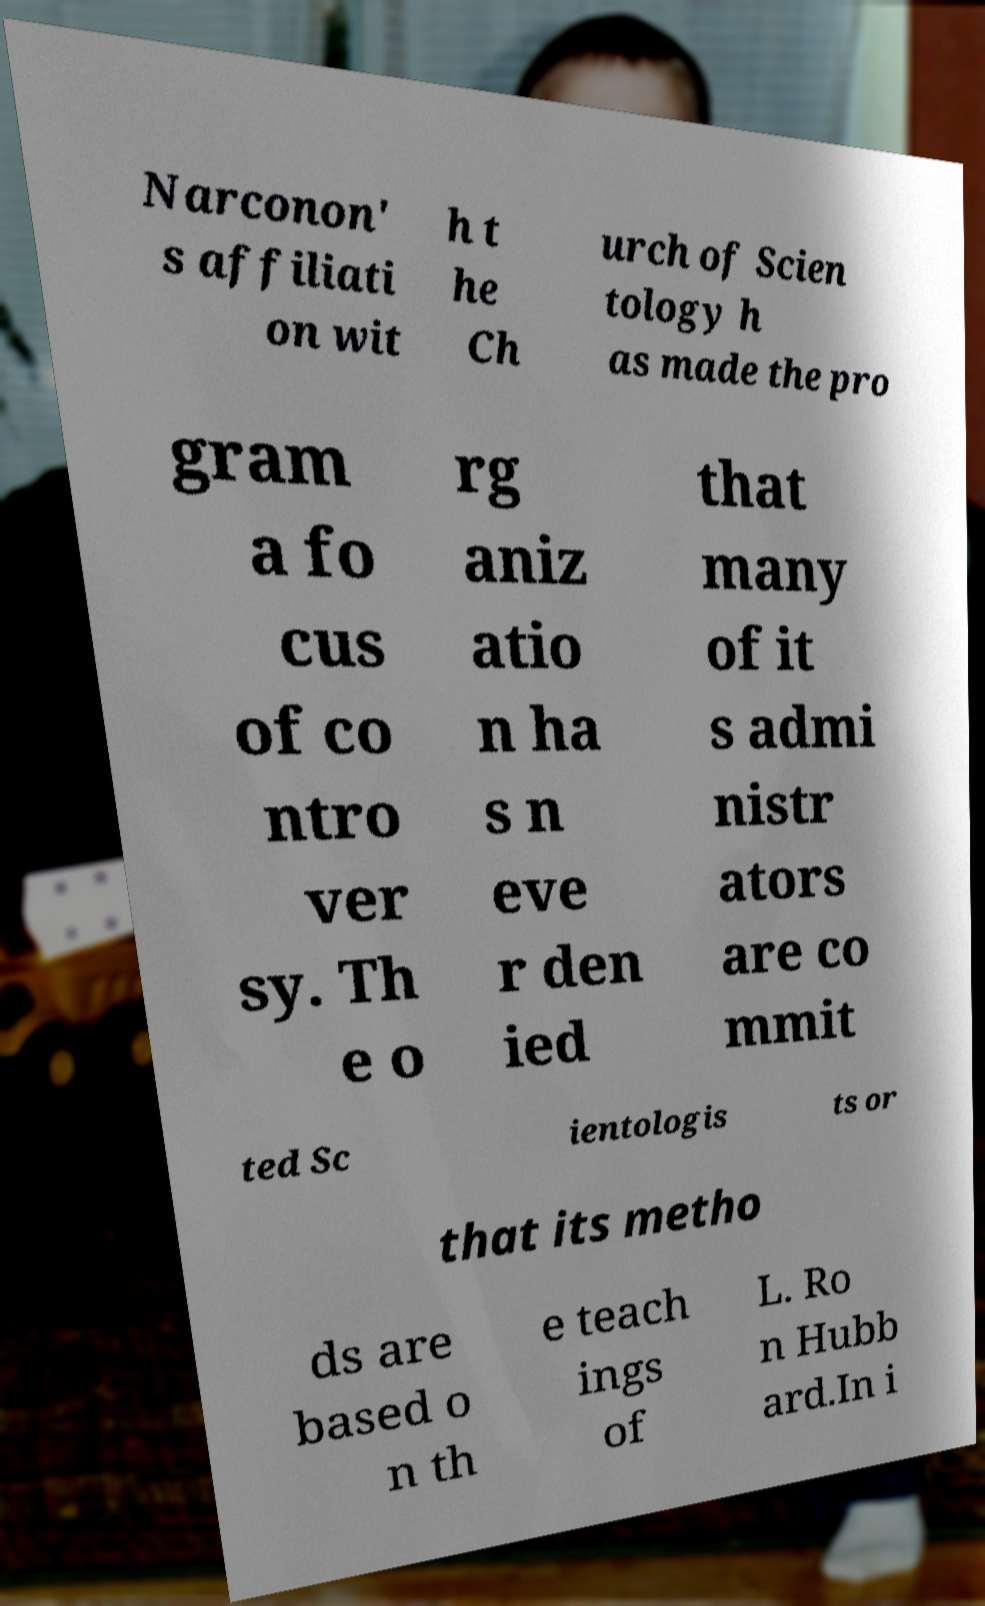I need the written content from this picture converted into text. Can you do that? Narconon' s affiliati on wit h t he Ch urch of Scien tology h as made the pro gram a fo cus of co ntro ver sy. Th e o rg aniz atio n ha s n eve r den ied that many of it s admi nistr ators are co mmit ted Sc ientologis ts or that its metho ds are based o n th e teach ings of L. Ro n Hubb ard.In i 